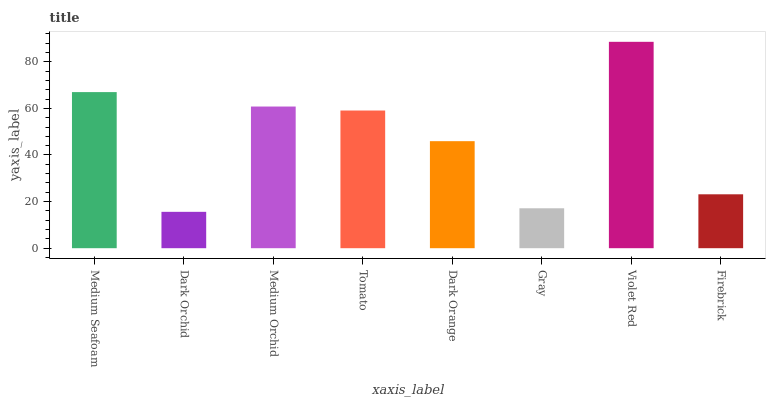Is Dark Orchid the minimum?
Answer yes or no. Yes. Is Violet Red the maximum?
Answer yes or no. Yes. Is Medium Orchid the minimum?
Answer yes or no. No. Is Medium Orchid the maximum?
Answer yes or no. No. Is Medium Orchid greater than Dark Orchid?
Answer yes or no. Yes. Is Dark Orchid less than Medium Orchid?
Answer yes or no. Yes. Is Dark Orchid greater than Medium Orchid?
Answer yes or no. No. Is Medium Orchid less than Dark Orchid?
Answer yes or no. No. Is Tomato the high median?
Answer yes or no. Yes. Is Dark Orange the low median?
Answer yes or no. Yes. Is Firebrick the high median?
Answer yes or no. No. Is Dark Orchid the low median?
Answer yes or no. No. 